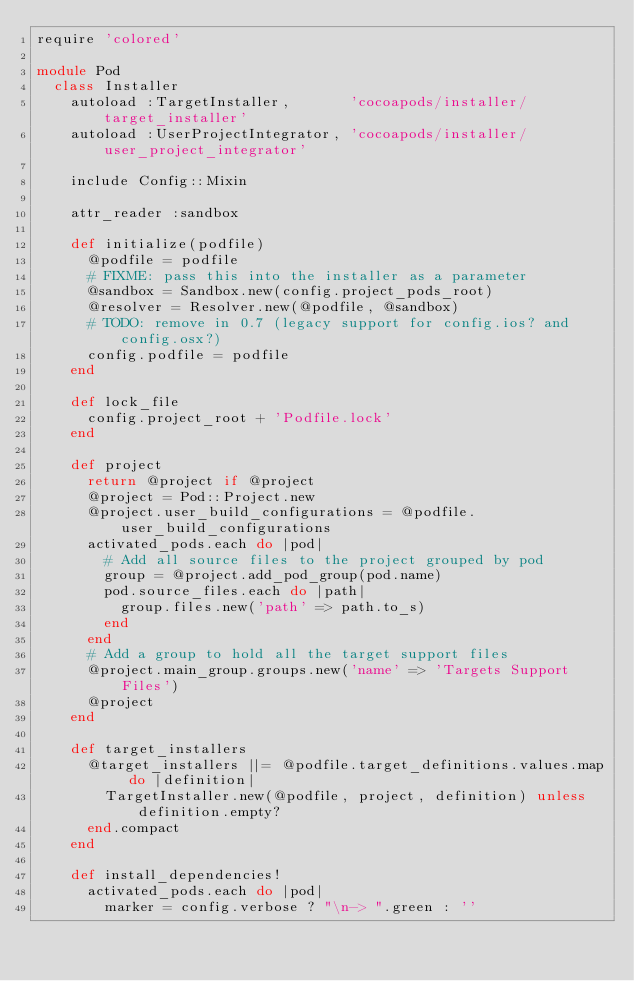Convert code to text. <code><loc_0><loc_0><loc_500><loc_500><_Ruby_>require 'colored'

module Pod
  class Installer
    autoload :TargetInstaller,       'cocoapods/installer/target_installer'
    autoload :UserProjectIntegrator, 'cocoapods/installer/user_project_integrator'

    include Config::Mixin

    attr_reader :sandbox

    def initialize(podfile)
      @podfile = podfile
      # FIXME: pass this into the installer as a parameter
      @sandbox = Sandbox.new(config.project_pods_root)
      @resolver = Resolver.new(@podfile, @sandbox)
      # TODO: remove in 0.7 (legacy support for config.ios? and config.osx?)
      config.podfile = podfile
    end

    def lock_file
      config.project_root + 'Podfile.lock'
    end

    def project
      return @project if @project
      @project = Pod::Project.new
      @project.user_build_configurations = @podfile.user_build_configurations
      activated_pods.each do |pod|
        # Add all source files to the project grouped by pod
        group = @project.add_pod_group(pod.name)
        pod.source_files.each do |path|
          group.files.new('path' => path.to_s)
        end
      end
      # Add a group to hold all the target support files
      @project.main_group.groups.new('name' => 'Targets Support Files')
      @project
    end

    def target_installers
      @target_installers ||= @podfile.target_definitions.values.map do |definition|
        TargetInstaller.new(@podfile, project, definition) unless definition.empty?
      end.compact
    end

    def install_dependencies!
      activated_pods.each do |pod|
        marker = config.verbose ? "\n-> ".green : ''
</code> 